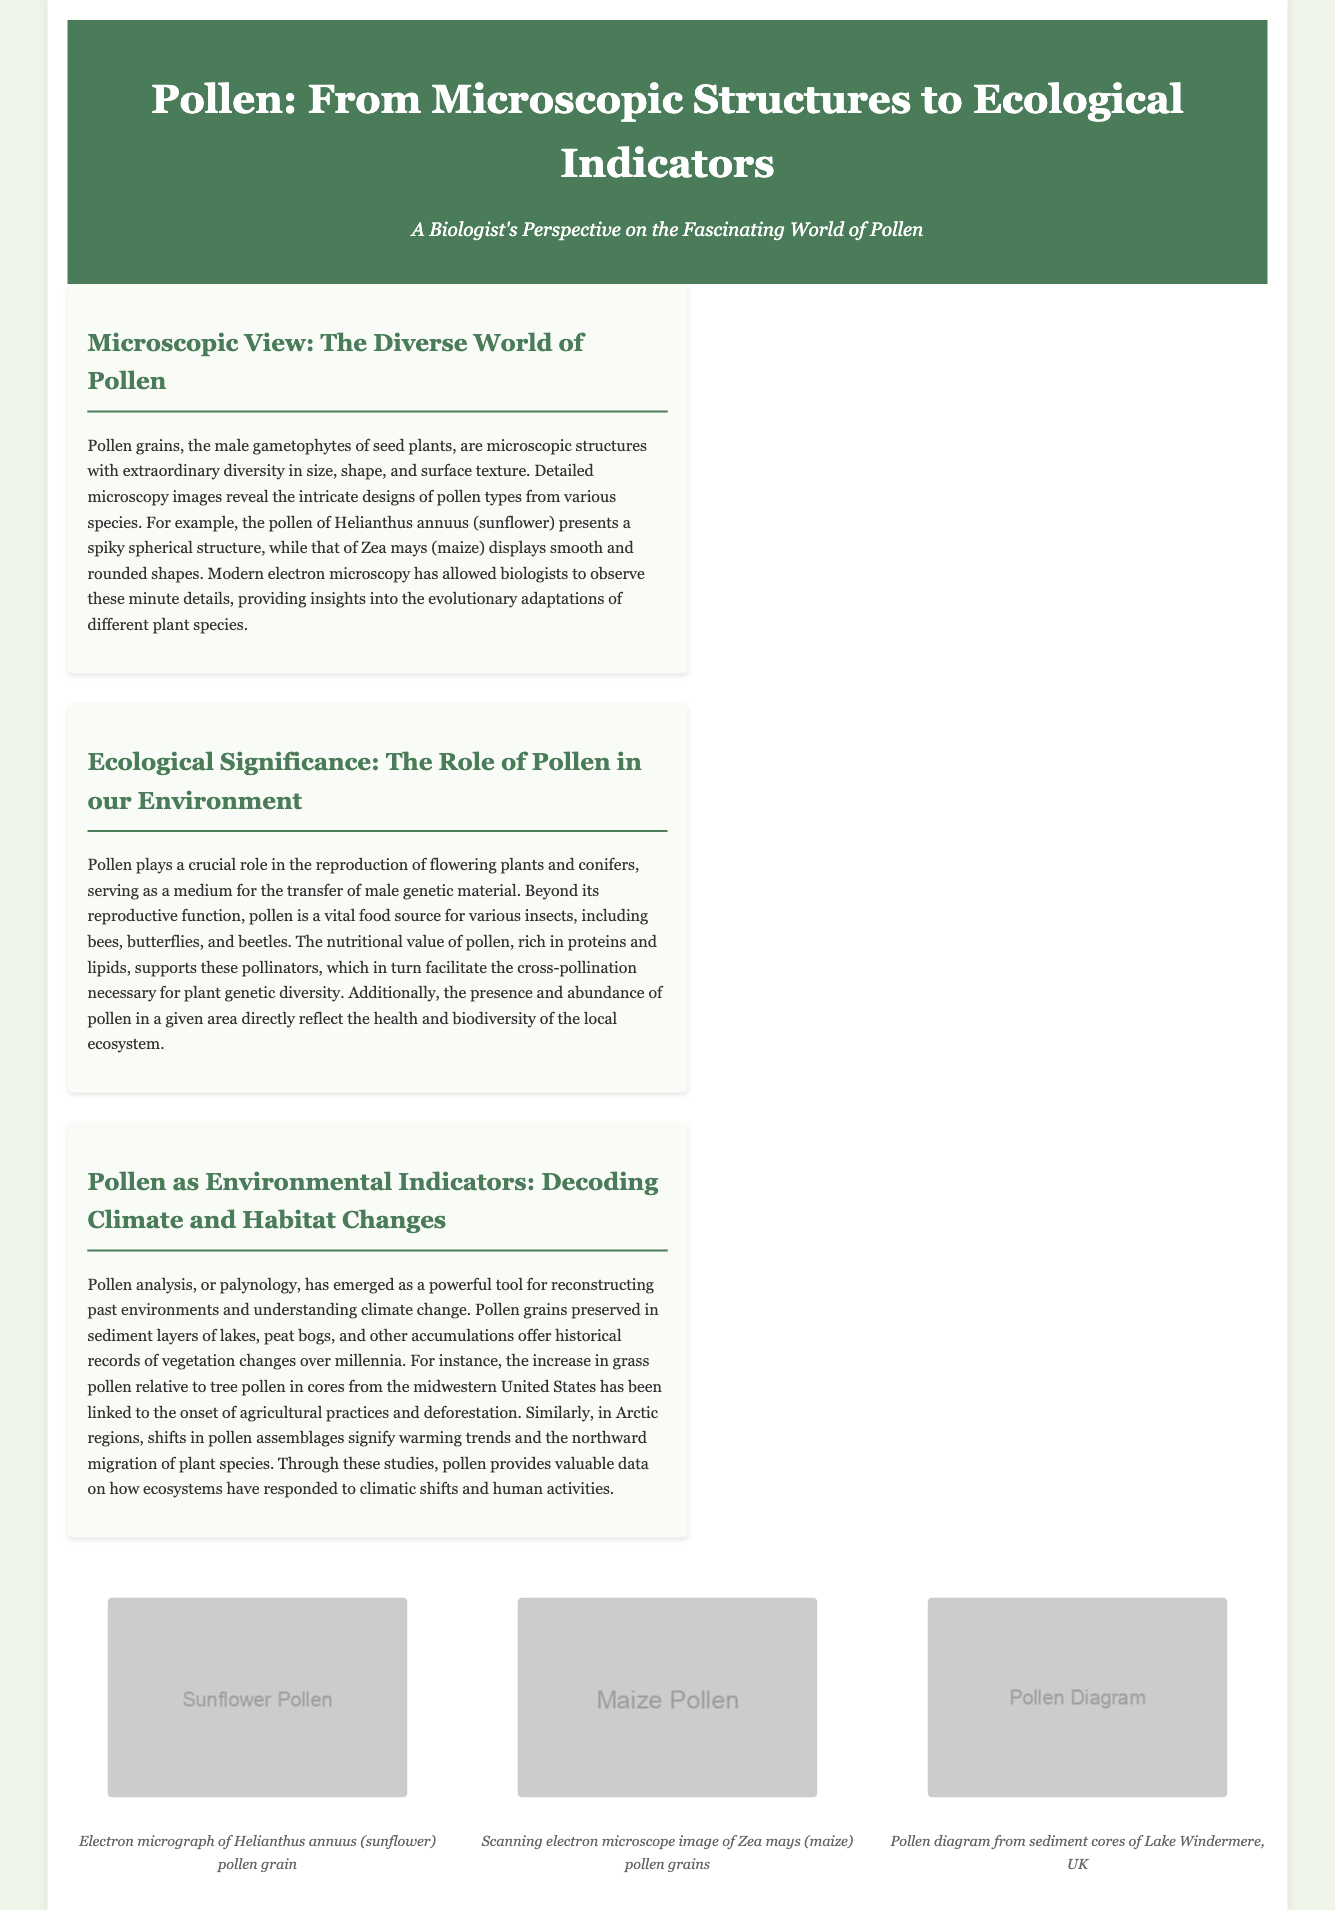What is the title of the document? The title is prominently displayed in the header section of the document.
Answer: Pollen: From Microscopic Structures to Ecological Indicators Which plant's pollen grain is described as presenting a spiky spherical structure? The description is found in the section discussing the diversity of pollen grains.
Answer: Helianthus annuus What role does pollen play in the reproduction of flowering plants? This information is mentioned in the article addressing ecological significance.
Answer: Transfer of male genetic material What is the term used for the analysis of pollen? The term is introduced in the section regarding pollen as environmental indicators.
Answer: Palynology In which region has the increase in grass pollen been linked to agricultural practices? The specific link is provided in the discussion of climate and habitat changes.
Answer: Midwestern United States What kind of organisms benefit from pollen as a food source? This detail can be found in the ecological significance article.
Answer: Insects What is observed through modern electron microscopy related to pollen? The article mentions the ability to see intricate designs through this method.
Answer: Minute details How many pollen diagrams are shown in the visuals section? The count can be determined by reviewing the visual images presented.
Answer: One 